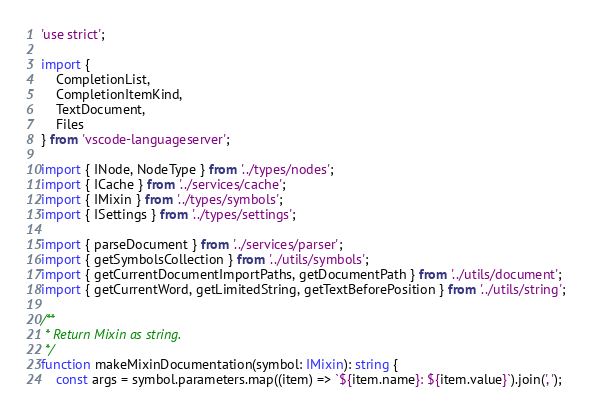Convert code to text. <code><loc_0><loc_0><loc_500><loc_500><_TypeScript_>'use strict';

import {
	CompletionList,
	CompletionItemKind,
	TextDocument,
	Files
} from 'vscode-languageserver';

import { INode, NodeType } from '../types/nodes';
import { ICache } from '../services/cache';
import { IMixin } from '../types/symbols';
import { ISettings } from '../types/settings';

import { parseDocument } from '../services/parser';
import { getSymbolsCollection } from '../utils/symbols';
import { getCurrentDocumentImportPaths, getDocumentPath } from '../utils/document';
import { getCurrentWord, getLimitedString, getTextBeforePosition } from '../utils/string';

/**
 * Return Mixin as string.
 */
function makeMixinDocumentation(symbol: IMixin): string {
	const args = symbol.parameters.map((item) => `${item.name}: ${item.value}`).join(', ');</code> 